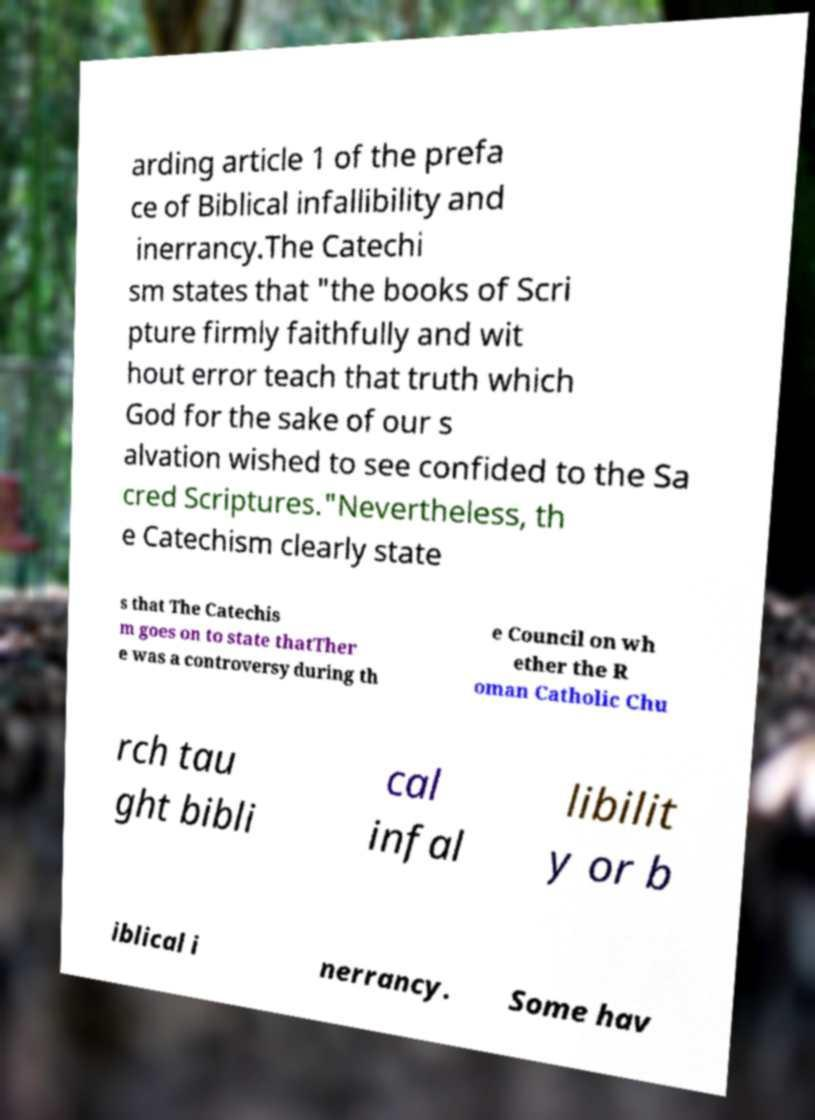Could you assist in decoding the text presented in this image and type it out clearly? arding article 1 of the prefa ce of Biblical infallibility and inerrancy.The Catechi sm states that "the books of Scri pture firmly faithfully and wit hout error teach that truth which God for the sake of our s alvation wished to see confided to the Sa cred Scriptures."Nevertheless, th e Catechism clearly state s that The Catechis m goes on to state thatTher e was a controversy during th e Council on wh ether the R oman Catholic Chu rch tau ght bibli cal infal libilit y or b iblical i nerrancy. Some hav 